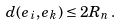<formula> <loc_0><loc_0><loc_500><loc_500>d ( e _ { i } , e _ { k } ) \leq 2 R _ { n } \, .</formula> 